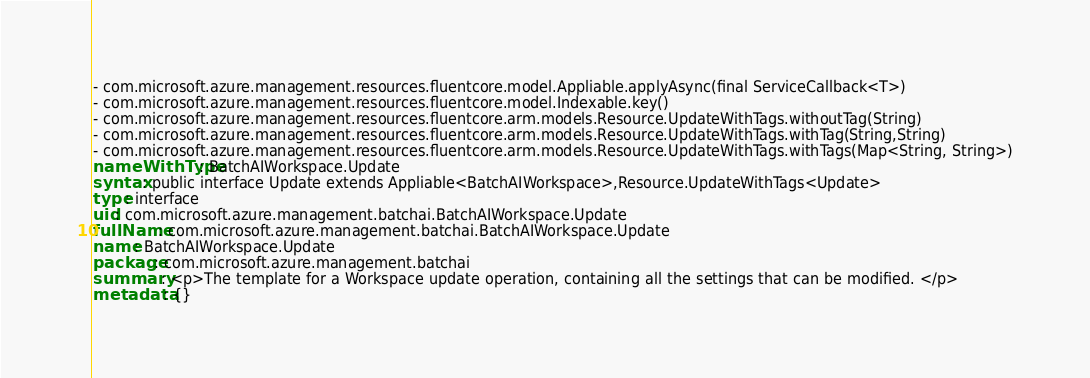Convert code to text. <code><loc_0><loc_0><loc_500><loc_500><_YAML_>- com.microsoft.azure.management.resources.fluentcore.model.Appliable.applyAsync(final ServiceCallback<T>)
- com.microsoft.azure.management.resources.fluentcore.model.Indexable.key()
- com.microsoft.azure.management.resources.fluentcore.arm.models.Resource.UpdateWithTags.withoutTag(String)
- com.microsoft.azure.management.resources.fluentcore.arm.models.Resource.UpdateWithTags.withTag(String,String)
- com.microsoft.azure.management.resources.fluentcore.arm.models.Resource.UpdateWithTags.withTags(Map<String, String>)
nameWithType: BatchAIWorkspace.Update
syntax: public interface Update extends Appliable<BatchAIWorkspace>,Resource.UpdateWithTags<Update>
type: interface
uid: com.microsoft.azure.management.batchai.BatchAIWorkspace.Update
fullName: com.microsoft.azure.management.batchai.BatchAIWorkspace.Update
name: BatchAIWorkspace.Update
package: com.microsoft.azure.management.batchai
summary: <p>The template for a Workspace update operation, containing all the settings that can be modified. </p>
metadata: {}
</code> 